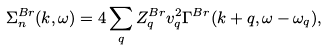Convert formula to latex. <formula><loc_0><loc_0><loc_500><loc_500>\Sigma ^ { B r } _ { n } ( k , \omega ) = 4 \sum _ { q } Z ^ { B r } _ { q } v _ { q } ^ { 2 } \Gamma ^ { B r } ( k + q , \omega - \omega _ { q } ) ,</formula> 